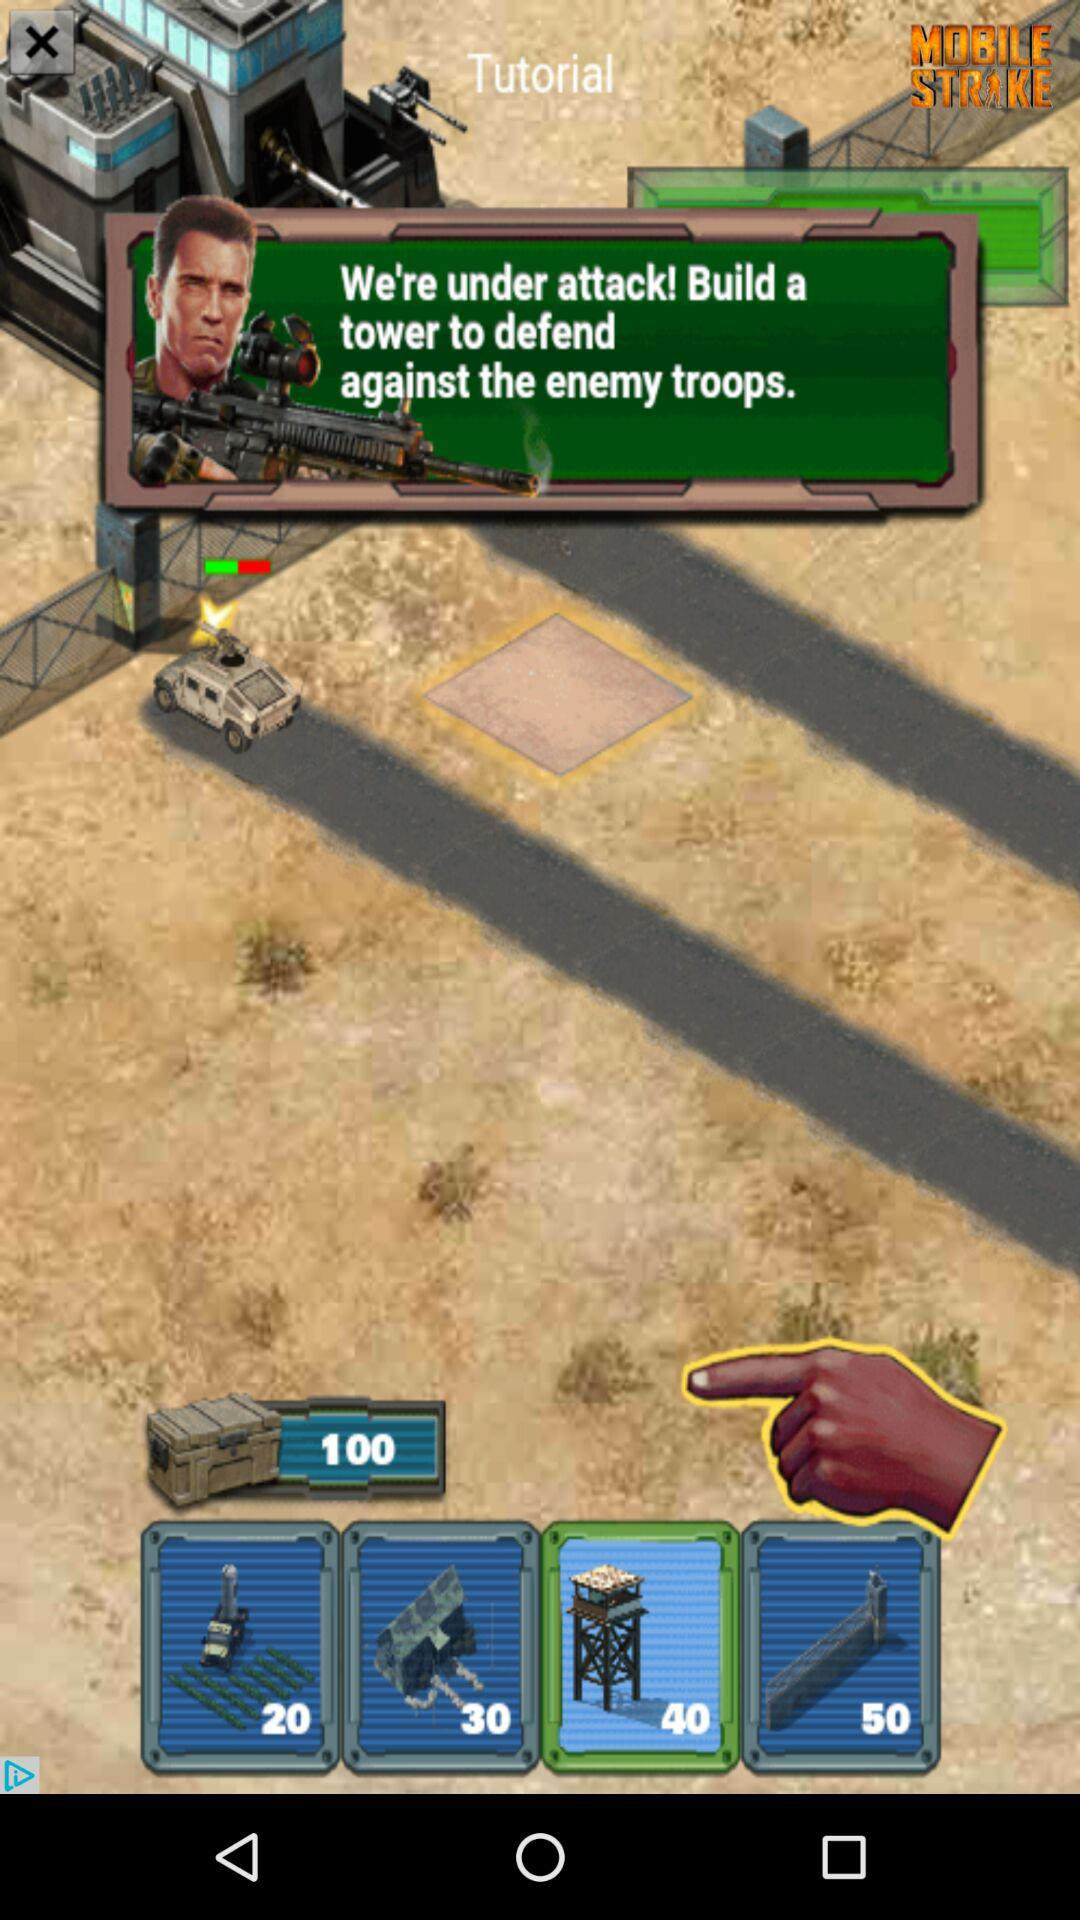How many more points are required to upgrade to the 50 point tower than the 20 point tower?
Answer the question using a single word or phrase. 30 